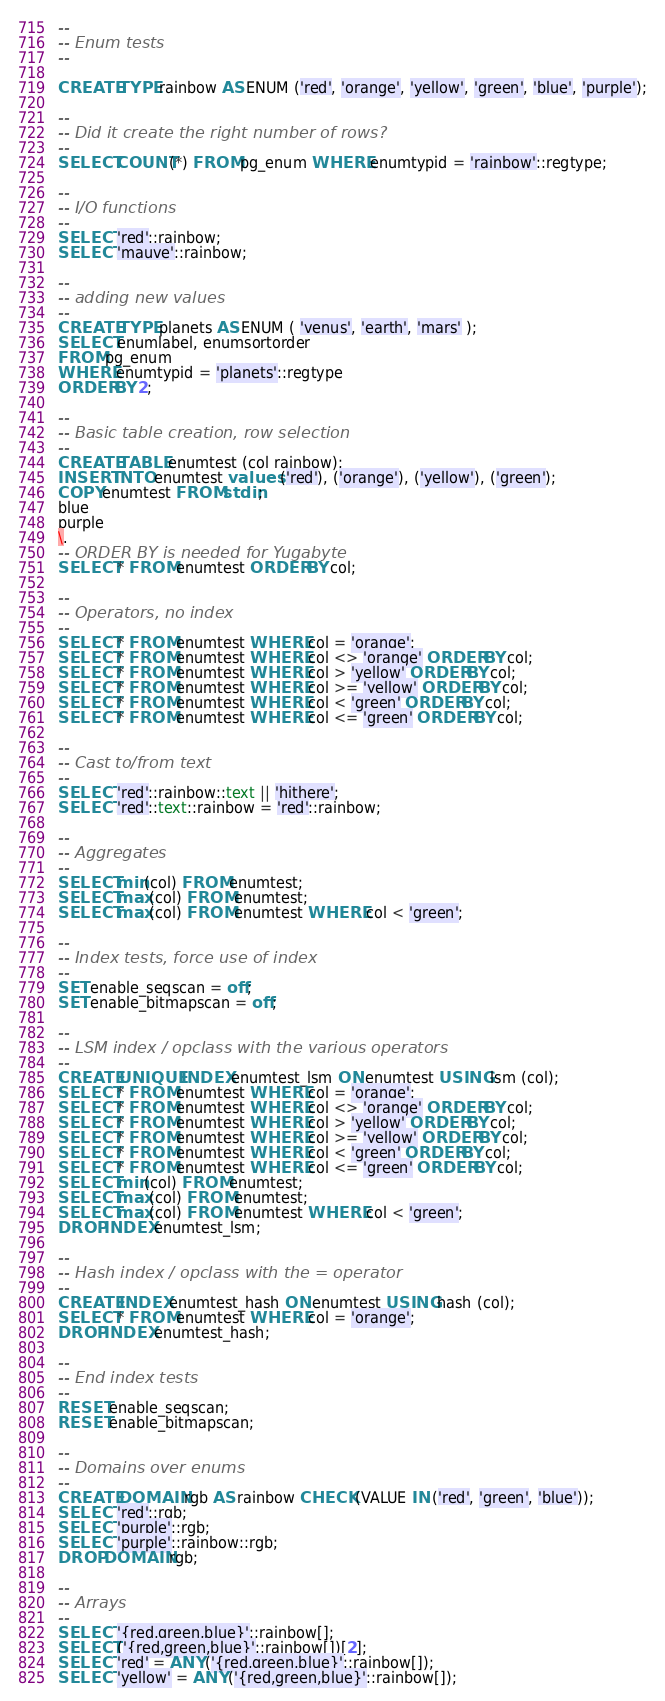<code> <loc_0><loc_0><loc_500><loc_500><_SQL_>--
-- Enum tests
--

CREATE TYPE rainbow AS ENUM ('red', 'orange', 'yellow', 'green', 'blue', 'purple');

--
-- Did it create the right number of rows?
--
SELECT COUNT(*) FROM pg_enum WHERE enumtypid = 'rainbow'::regtype;

--
-- I/O functions
--
SELECT 'red'::rainbow;
SELECT 'mauve'::rainbow;

--
-- adding new values
--
CREATE TYPE planets AS ENUM ( 'venus', 'earth', 'mars' );
SELECT enumlabel, enumsortorder
FROM pg_enum
WHERE enumtypid = 'planets'::regtype
ORDER BY 2;

--
-- Basic table creation, row selection
--
CREATE TABLE enumtest (col rainbow);
INSERT INTO enumtest values ('red'), ('orange'), ('yellow'), ('green');
COPY enumtest FROM stdin;
blue
purple
\.
-- ORDER BY is needed for Yugabyte
SELECT * FROM enumtest ORDER BY col;

--
-- Operators, no index
--
SELECT * FROM enumtest WHERE col = 'orange';
SELECT * FROM enumtest WHERE col <> 'orange' ORDER BY col;
SELECT * FROM enumtest WHERE col > 'yellow' ORDER BY col;
SELECT * FROM enumtest WHERE col >= 'yellow' ORDER BY col;
SELECT * FROM enumtest WHERE col < 'green' ORDER BY col;
SELECT * FROM enumtest WHERE col <= 'green' ORDER BY col;

--
-- Cast to/from text
--
SELECT 'red'::rainbow::text || 'hithere';
SELECT 'red'::text::rainbow = 'red'::rainbow;

--
-- Aggregates
--
SELECT min(col) FROM enumtest;
SELECT max(col) FROM enumtest;
SELECT max(col) FROM enumtest WHERE col < 'green';

--
-- Index tests, force use of index
--
SET enable_seqscan = off;
SET enable_bitmapscan = off;

--
-- LSM index / opclass with the various operators
--
CREATE UNIQUE INDEX enumtest_lsm ON enumtest USING lsm (col);
SELECT * FROM enumtest WHERE col = 'orange';
SELECT * FROM enumtest WHERE col <> 'orange' ORDER BY col;
SELECT * FROM enumtest WHERE col > 'yellow' ORDER BY col;
SELECT * FROM enumtest WHERE col >= 'yellow' ORDER BY col;
SELECT * FROM enumtest WHERE col < 'green' ORDER BY col;
SELECT * FROM enumtest WHERE col <= 'green' ORDER BY col;
SELECT min(col) FROM enumtest;
SELECT max(col) FROM enumtest;
SELECT max(col) FROM enumtest WHERE col < 'green';
DROP INDEX enumtest_lsm;

--
-- Hash index / opclass with the = operator
--
CREATE INDEX enumtest_hash ON enumtest USING hash (col);
SELECT * FROM enumtest WHERE col = 'orange';
DROP INDEX enumtest_hash;

--
-- End index tests
--
RESET enable_seqscan;
RESET enable_bitmapscan;

--
-- Domains over enums
--
CREATE DOMAIN rgb AS rainbow CHECK (VALUE IN ('red', 'green', 'blue'));
SELECT 'red'::rgb;
SELECT 'purple'::rgb;
SELECT 'purple'::rainbow::rgb;
DROP DOMAIN rgb;

--
-- Arrays
--
SELECT '{red,green,blue}'::rainbow[];
SELECT ('{red,green,blue}'::rainbow[])[2];
SELECT 'red' = ANY ('{red,green,blue}'::rainbow[]);
SELECT 'yellow' = ANY ('{red,green,blue}'::rainbow[]);</code> 